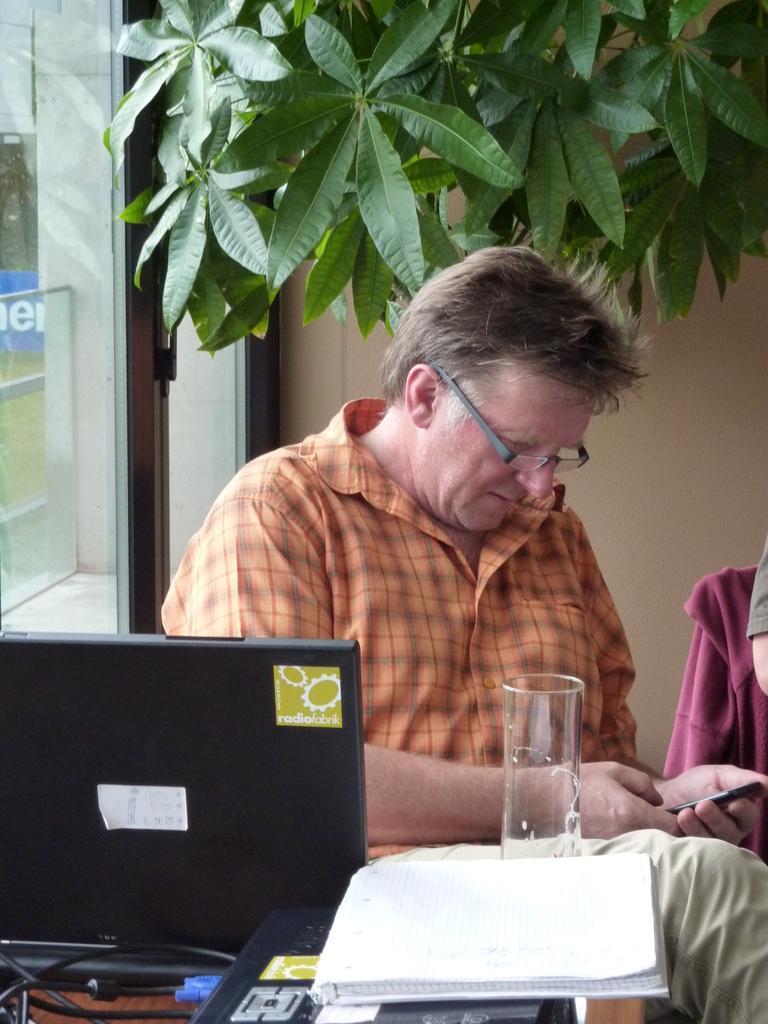In one or two sentences, can you explain what this image depicts? In this picture we can see a man who is sitting on the chair. This is table. On the table there is a monitor, book, and a glass. On the background we can see a plant. And this is the wall. 